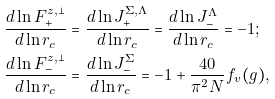<formula> <loc_0><loc_0><loc_500><loc_500>& \frac { d \ln F _ { + } ^ { z , \perp } } { d \ln r _ { c } } = \frac { d \ln J _ { + } ^ { \Sigma , \Lambda } } { d \ln r _ { c } } = \frac { d \ln J _ { - } ^ { \Lambda } } { d \ln r _ { c } } = - 1 ; \\ & \frac { d \ln F _ { - } ^ { z , \perp } } { d \ln r _ { c } } = \frac { d \ln J _ { - } ^ { \Sigma } } { d \ln r _ { c } } = - 1 + \frac { 4 0 } { \pi ^ { 2 } N } f _ { v } ( g ) ,</formula> 